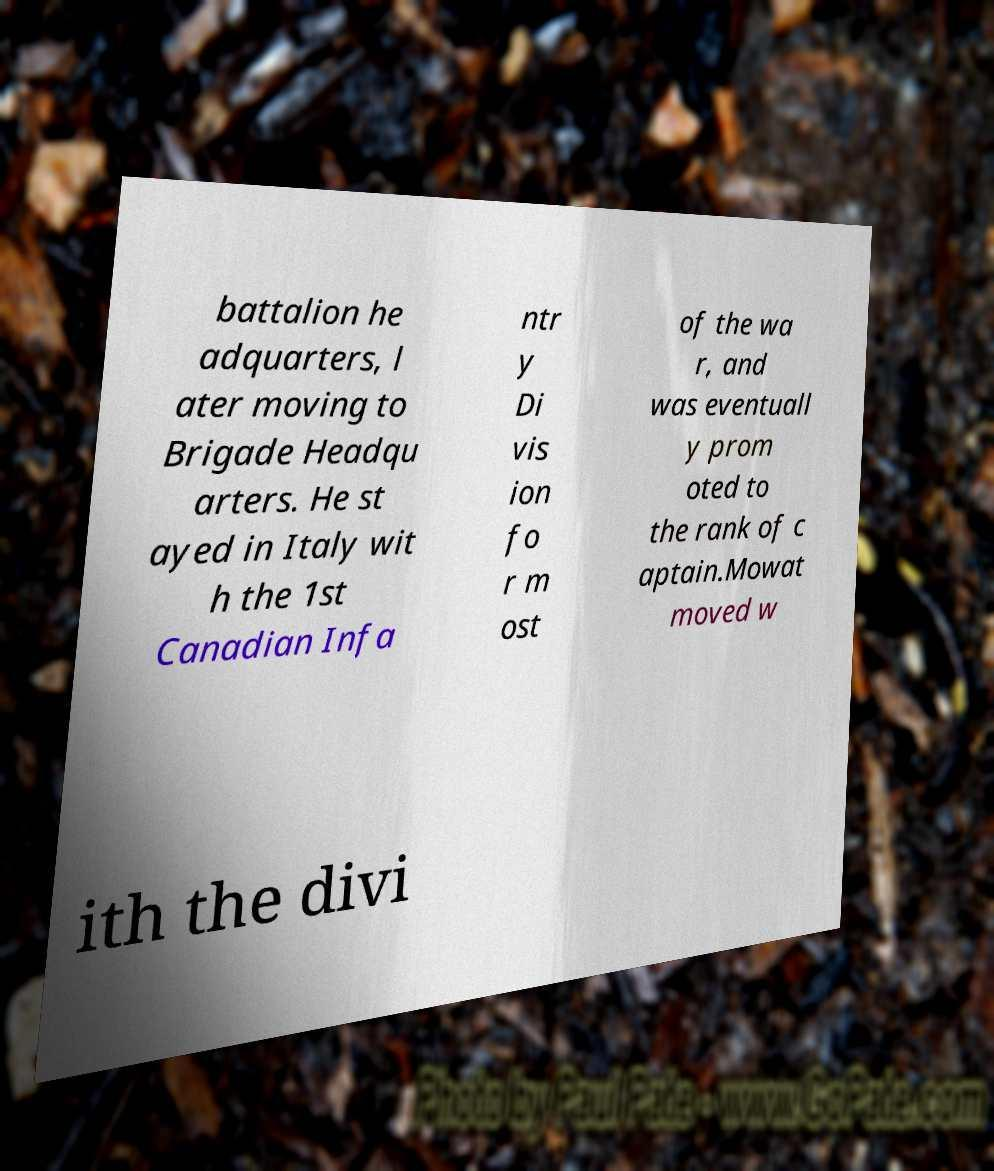Could you extract and type out the text from this image? battalion he adquarters, l ater moving to Brigade Headqu arters. He st ayed in Italy wit h the 1st Canadian Infa ntr y Di vis ion fo r m ost of the wa r, and was eventuall y prom oted to the rank of c aptain.Mowat moved w ith the divi 